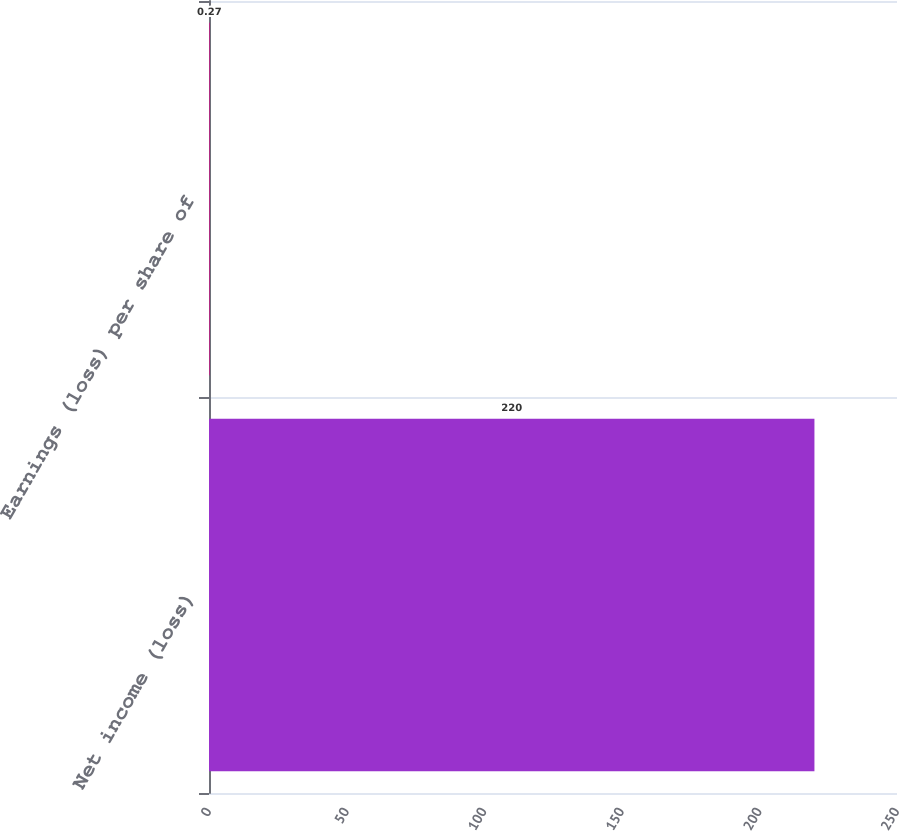Convert chart. <chart><loc_0><loc_0><loc_500><loc_500><bar_chart><fcel>Net income (loss)<fcel>Earnings (loss) per share of<nl><fcel>220<fcel>0.27<nl></chart> 